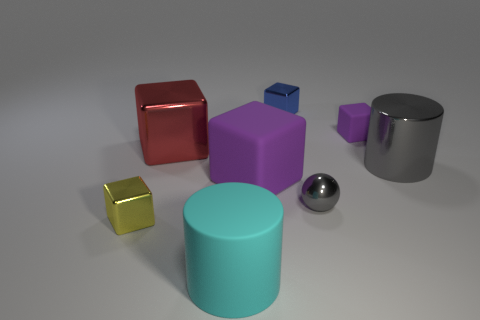Subtract all red metallic cubes. How many cubes are left? 4 Subtract all balls. How many objects are left? 7 Subtract all gray cubes. How many cyan cylinders are left? 1 Add 3 brown shiny cylinders. How many brown shiny cylinders exist? 3 Add 1 big cyan rubber cylinders. How many objects exist? 9 Subtract all yellow blocks. How many blocks are left? 4 Subtract 1 gray spheres. How many objects are left? 7 Subtract 1 cylinders. How many cylinders are left? 1 Subtract all blue blocks. Subtract all yellow cylinders. How many blocks are left? 4 Subtract all cylinders. Subtract all small purple things. How many objects are left? 5 